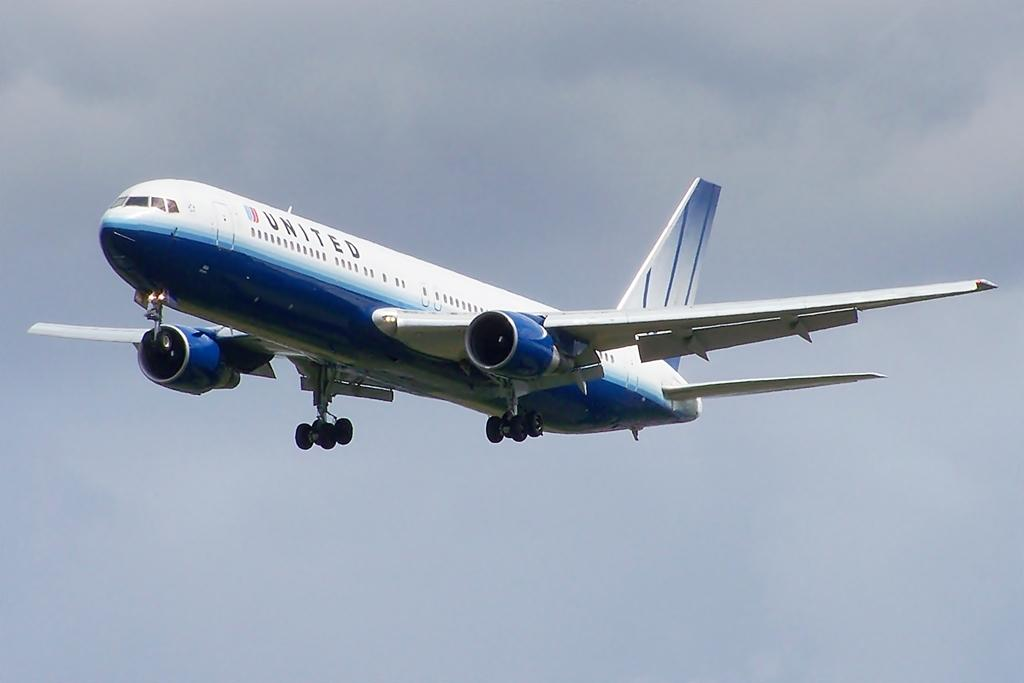What is the main subject of the image? The main subject of the image is an airplane. Can you describe the position of the airplane in the image? The airplane is in the air. What shape are the toes of the airplane in the image? Airplanes do not have toes, as they are machines and not living beings. 